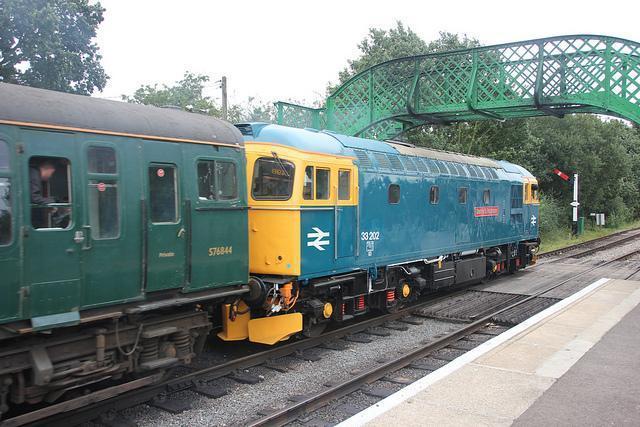How many white circles are on the yellow part of the train?
Give a very brief answer. 0. 